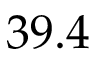<formula> <loc_0><loc_0><loc_500><loc_500>3 9 . 4</formula> 